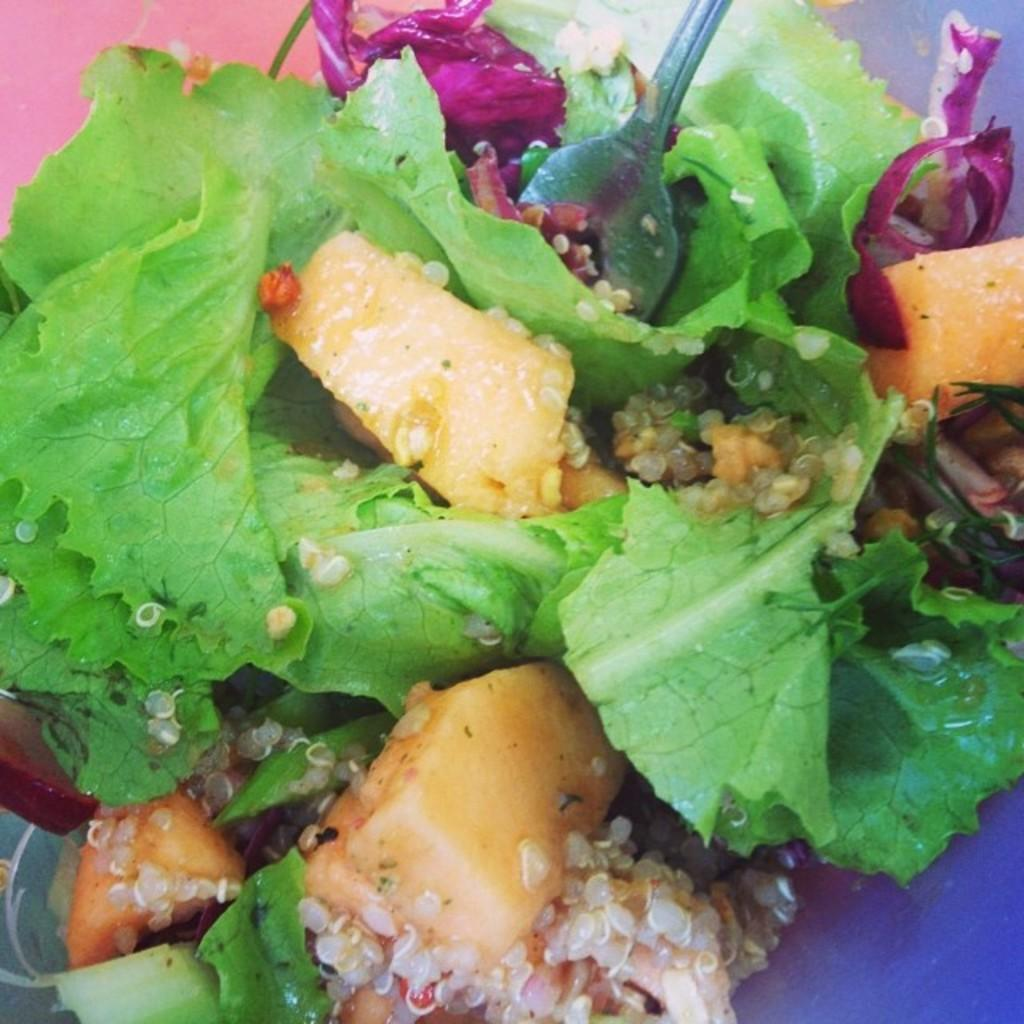What type of food is visible in the image? There is a salad in the image. What utensil is present in the image? There is a fork in the image. Where is the fork located in the image? The fork is in a plate. What memory does the rock in the image evoke for the person who took the photo? There is: There is no rock present in the image, so it cannot evoke any memories. 